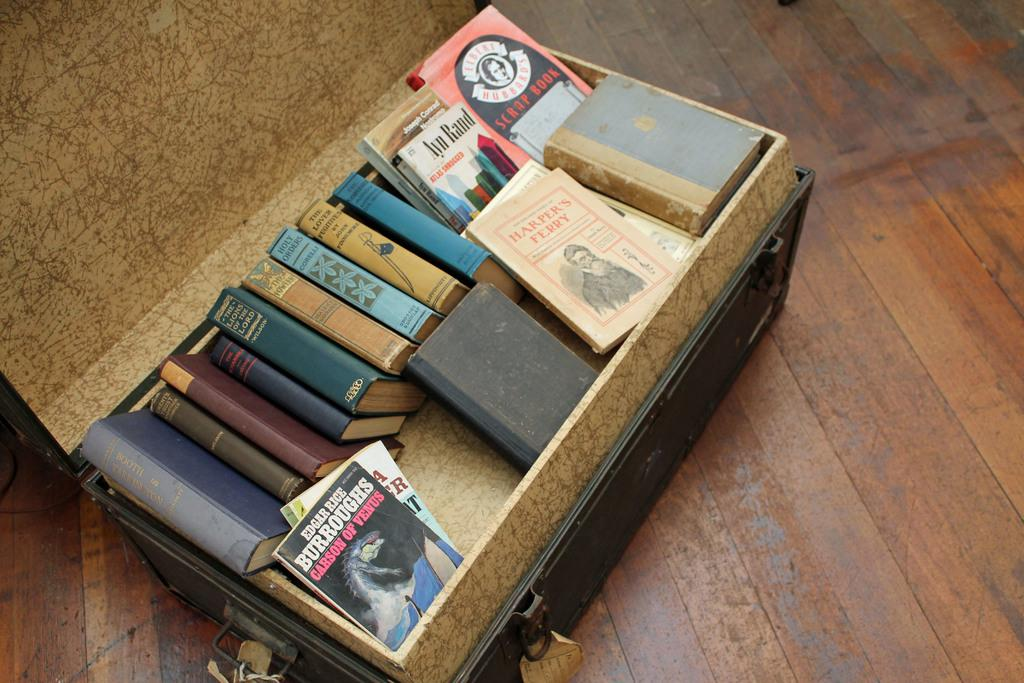<image>
Write a terse but informative summary of the picture. A bunch of older books in a suitcase one of which is by Edgar Rice. 